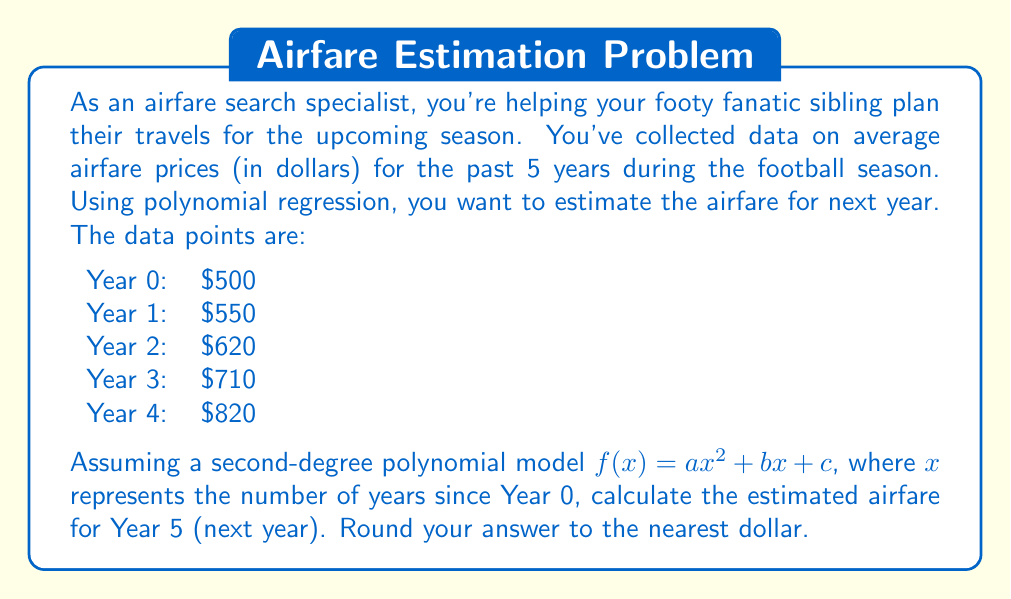Provide a solution to this math problem. To solve this problem, we need to use polynomial regression to find the coefficients $a$, $b$, and $c$ of our second-degree polynomial model. We'll use the least squares method to find these coefficients.

1. Set up the system of normal equations:
   $$\begin{cases}
   \sum y = an\sum x^2 + b\sum x + nc \\
   \sum xy = a\sum x^3 + b\sum x^2 + c\sum x \\
   \sum x^2y = a\sum x^4 + b\sum x^3 + c\sum x^2
   \end{cases}$$

2. Calculate the sums:
   $\sum x = 0 + 1 + 2 + 3 + 4 = 10$
   $\sum x^2 = 0 + 1 + 4 + 9 + 16 = 30$
   $\sum x^3 = 0 + 1 + 8 + 27 + 64 = 100$
   $\sum x^4 = 0 + 1 + 16 + 81 + 256 = 354$
   $\sum y = 500 + 550 + 620 + 710 + 820 = 3200$
   $\sum xy = 0 + 550 + 1240 + 2130 + 3280 = 7200$
   $\sum x^2y = 0 + 550 + 2480 + 6390 + 13120 = 22540$

3. Substitute these values into the normal equations:
   $$\begin{cases}
   3200 = 30a + 10b + 5c \\
   7200 = 100a + 30b + 10c \\
   22540 = 354a + 100b + 30c
   \end{cases}$$

4. Solve this system of equations (using a matrix method or elimination):
   $a = 10$
   $b = 40$
   $c = 500$

5. Our polynomial model is therefore:
   $f(x) = 10x^2 + 40x + 500$

6. To estimate the airfare for Year 5, we substitute $x = 5$ into our model:
   $f(5) = 10(5^2) + 40(5) + 500$
   $f(5) = 10(25) + 200 + 500$
   $f(5) = 250 + 200 + 500 = 950$

Therefore, the estimated airfare for Year 5 is $950.
Answer: $950 